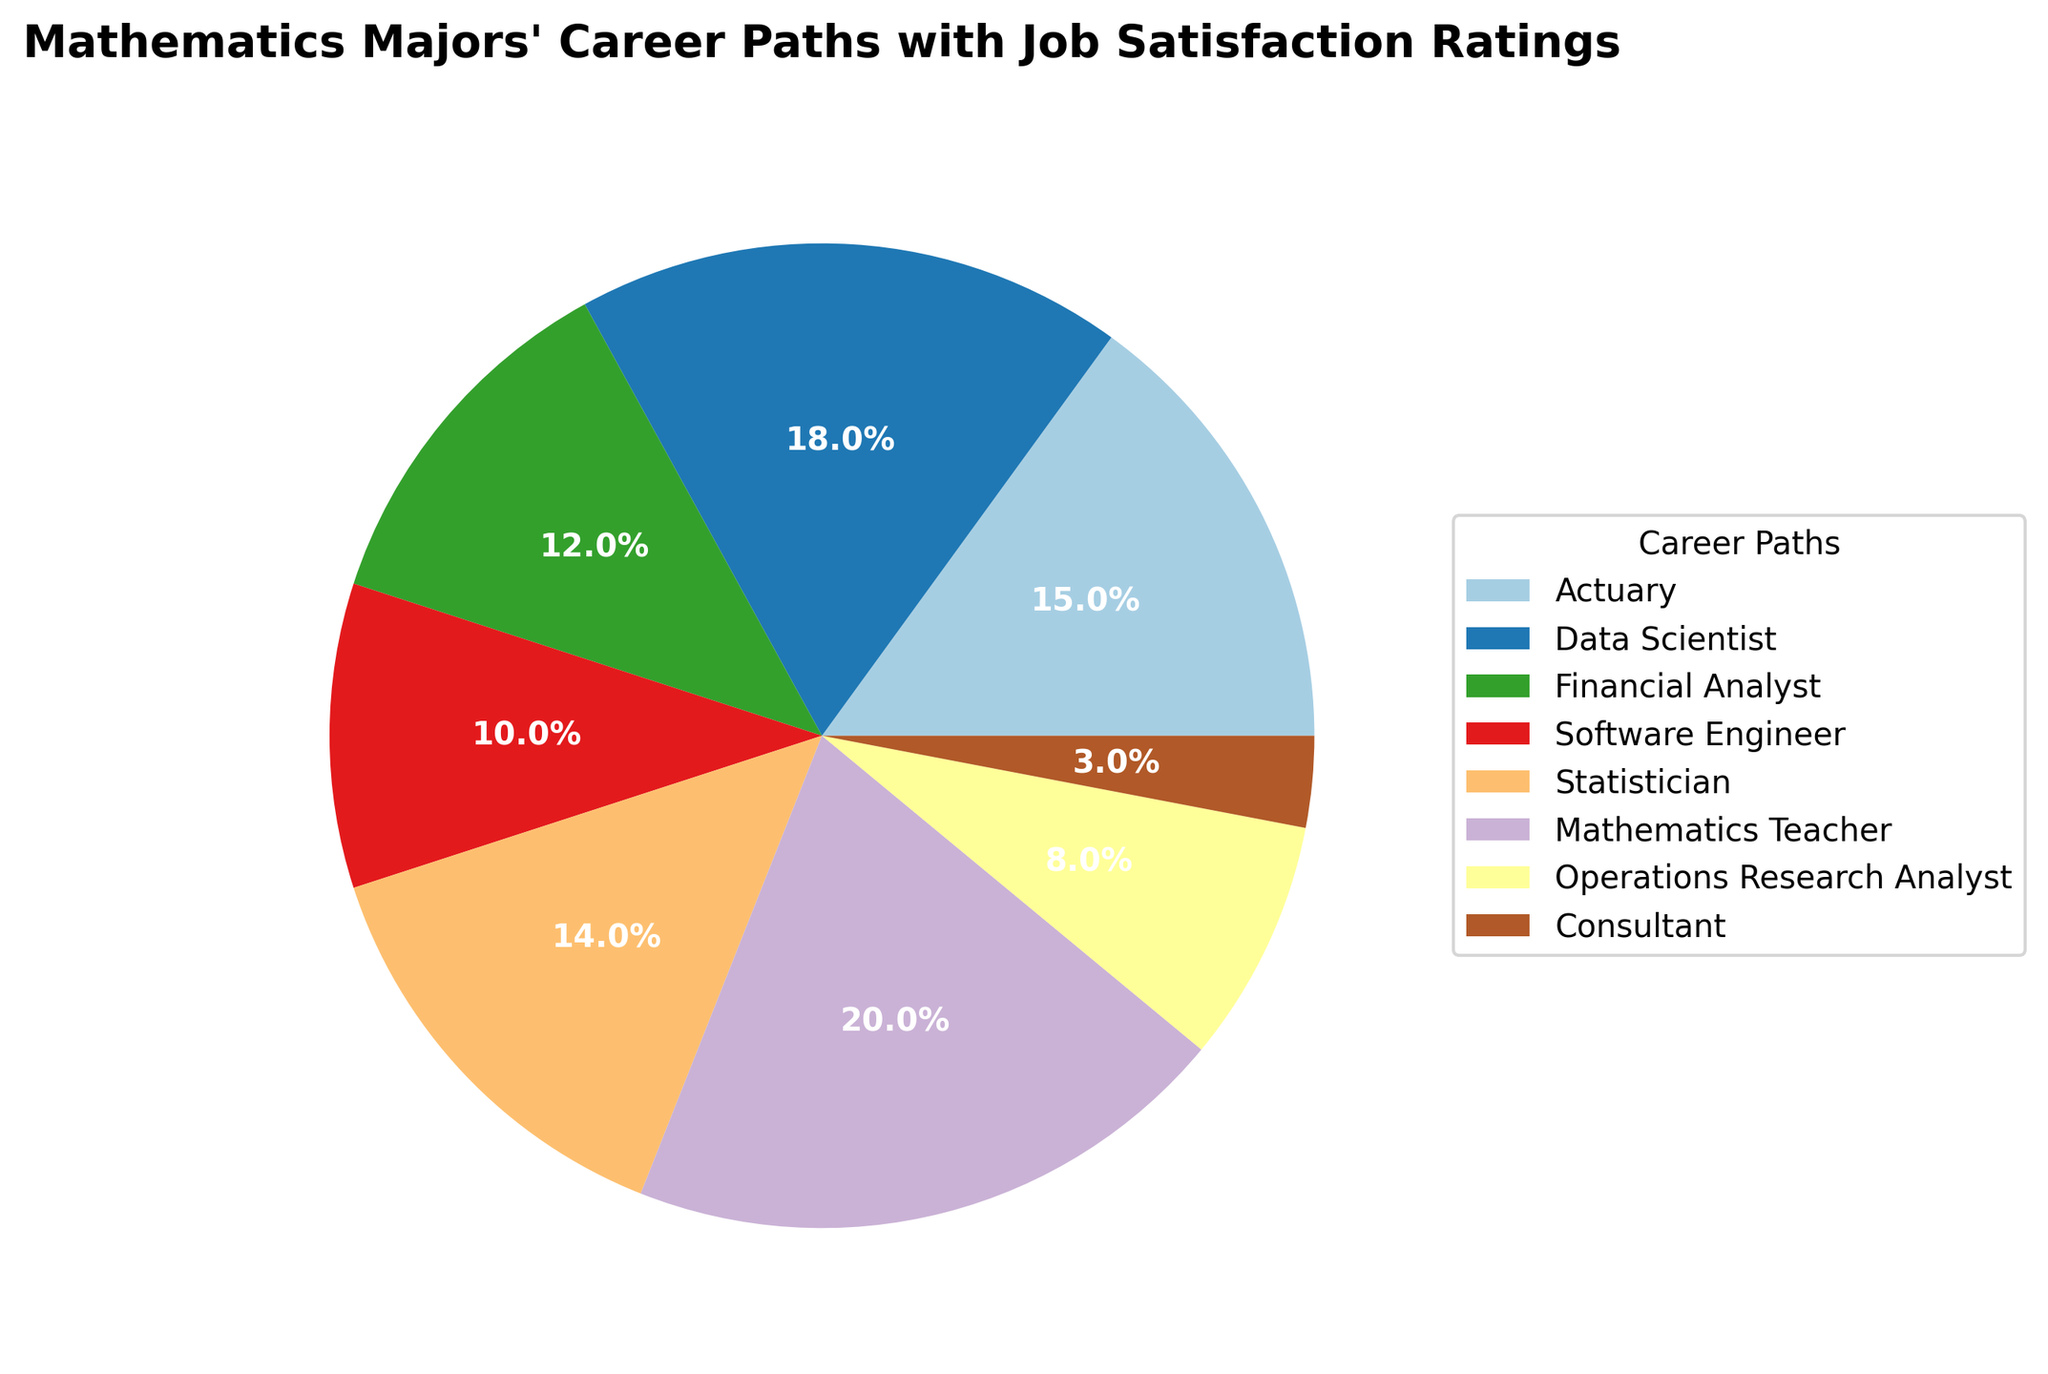What's the total percentage of Mathematics majors working as Actuaries, Data Scientists, and Financial Analysts? The pie chart shows the percentage of Mathematics majors in each career path. Sum the percentages for Actuary (15%), Data Scientist (18%), and Financial Analyst (12%). 15 + 18 + 12 = 45
Answer: 45% Which career path has the highest job satisfaction rating? The job satisfaction ratings are labeled in the data for each career path. The highest rating is 9.0 for Data Scientist.
Answer: Data Scientist What is the difference in job satisfaction ratings between Mathematics Teachers and Software Engineers? The job satisfaction rating for Mathematics Teacher is 7.5 and for Software Engineer is 8.2. Subtract the former from the latter: 8.2 - 7.5 = 0.7
Answer: 0.7 Which career paths occupy at least 10% of the overall career paths? By inspecting the percentages in the pie chart, the career paths at least 10% are Data Scientist (18%), Mathematics Teacher (20%), Actuary (15%), and Financial Analyst (12%).
Answer: Data Scientist, Mathematics Teacher, Actuary, Financial Analyst What is the average job satisfaction rating of Actuary, Statistician, and Operations Research Analyst combined? The job satisfaction ratings for Actuary, Statistician, and Operations Research Analyst are 8.5, 8.7, and 8.0 respectively. Sum these ratings and divide by the number of careers: (8.5 + 8.7 + 8.0) / 3 = 8.4
Answer: 8.4 Which career path has the smallest representation in the pie chart, and what percentage does it represent? By checking the figure, Consultant has the smallest representation with 3%.
Answer: Consultant, 3% Is the job satisfaction rating for Data Scientists higher or lower than the average job satisfaction of all the career paths? To find the average job satisfaction, sum all ratings and divide by the number of careers: (8.5 + 9.0 + 7.8 + 8.2 + 8.7 + 7.5 + 8.0 + 7.2) / 8 = 8.11. Data Scientist has a rating of 9.0, which is higher than 8.11.
Answer: Higher Which career path has a job satisfaction rating closest to 8.0? Look at the job satisfaction ratings. Operations Research Analyst has a rating of 8.0, which is the closest.
Answer: Operations Research Analyst What is the combined percentage of Mathematics majors working in careers with job satisfaction ratings above 8.0? Careers with ratings above 8.0 are Actuary (15%), Data Scientist (18%), Software Engineer (10%), Statistician (14%), and Operations Research Analyst (8%). Sum these percentages: 15 + 18 + 10 + 14 + 8 = 65
Answer: 65% Compare the total representation of Actuary, Statistician, and Operations Research Analyst to the total representation of Mathematics Teacher and Consultant. Which is higher? First, calculate total representation for each group. Actuary (15%) + Statistician (14%) + Operations Research Analyst (8%) = 37%. Mathematics Teacher (20%) + Consultant (3%) = 23%. 37% is higher.
Answer: Actuary, Statistician, and Operations Research Analyst 